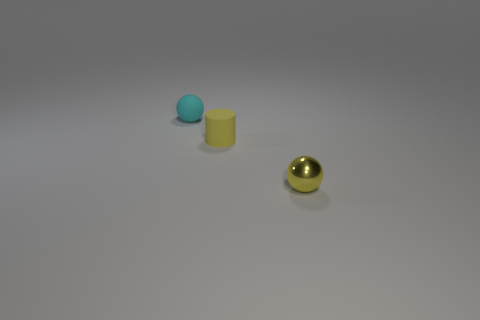Is there anything else that has the same material as the yellow sphere?
Offer a terse response. No. Is the color of the tiny rubber object in front of the matte sphere the same as the metallic ball?
Offer a terse response. Yes. Does the small object to the right of the yellow matte cylinder have the same shape as the cyan thing?
Keep it short and to the point. Yes. What color is the sphere behind the yellow ball on the right side of the tiny cyan object?
Your answer should be very brief. Cyan. Is the number of big gray objects less than the number of spheres?
Provide a short and direct response. Yes. Is there a yellow cylinder that has the same material as the tiny cyan object?
Offer a very short reply. Yes. Does the yellow metal thing have the same shape as the matte thing to the left of the yellow matte thing?
Offer a very short reply. Yes. Are there any yellow balls in front of the yellow metal object?
Your answer should be compact. No. How many small cyan matte objects have the same shape as the yellow rubber thing?
Offer a terse response. 0. Is the material of the small yellow ball the same as the sphere that is behind the small yellow cylinder?
Your response must be concise. No. 